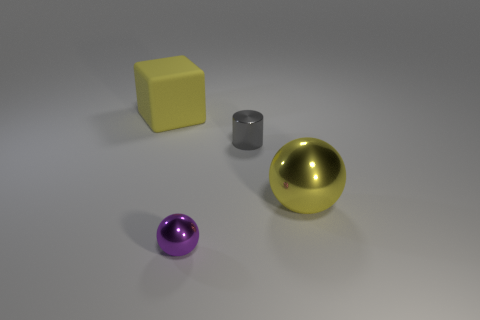Is the large rubber object the same color as the large metallic thing?
Give a very brief answer. Yes. There is a yellow object that is on the right side of the tiny gray metallic cylinder; what number of large matte cubes are left of it?
Provide a succinct answer. 1. Does the cylinder have the same material as the small purple ball?
Provide a succinct answer. Yes. Is there a tiny blue thing that has the same material as the large sphere?
Keep it short and to the point. No. What is the color of the cylinder that is left of the large yellow object that is in front of the big thing that is left of the big yellow metal object?
Your answer should be compact. Gray. How many yellow objects are blocks or spheres?
Keep it short and to the point. 2. What number of other large objects are the same shape as the purple object?
Keep it short and to the point. 1. There is a yellow object that is the same size as the yellow rubber block; what is its shape?
Provide a succinct answer. Sphere. There is a big yellow rubber object; are there any large yellow rubber cubes on the left side of it?
Your answer should be very brief. No. Is there a small gray metallic cylinder right of the yellow thing that is on the right side of the yellow matte thing?
Offer a terse response. No. 